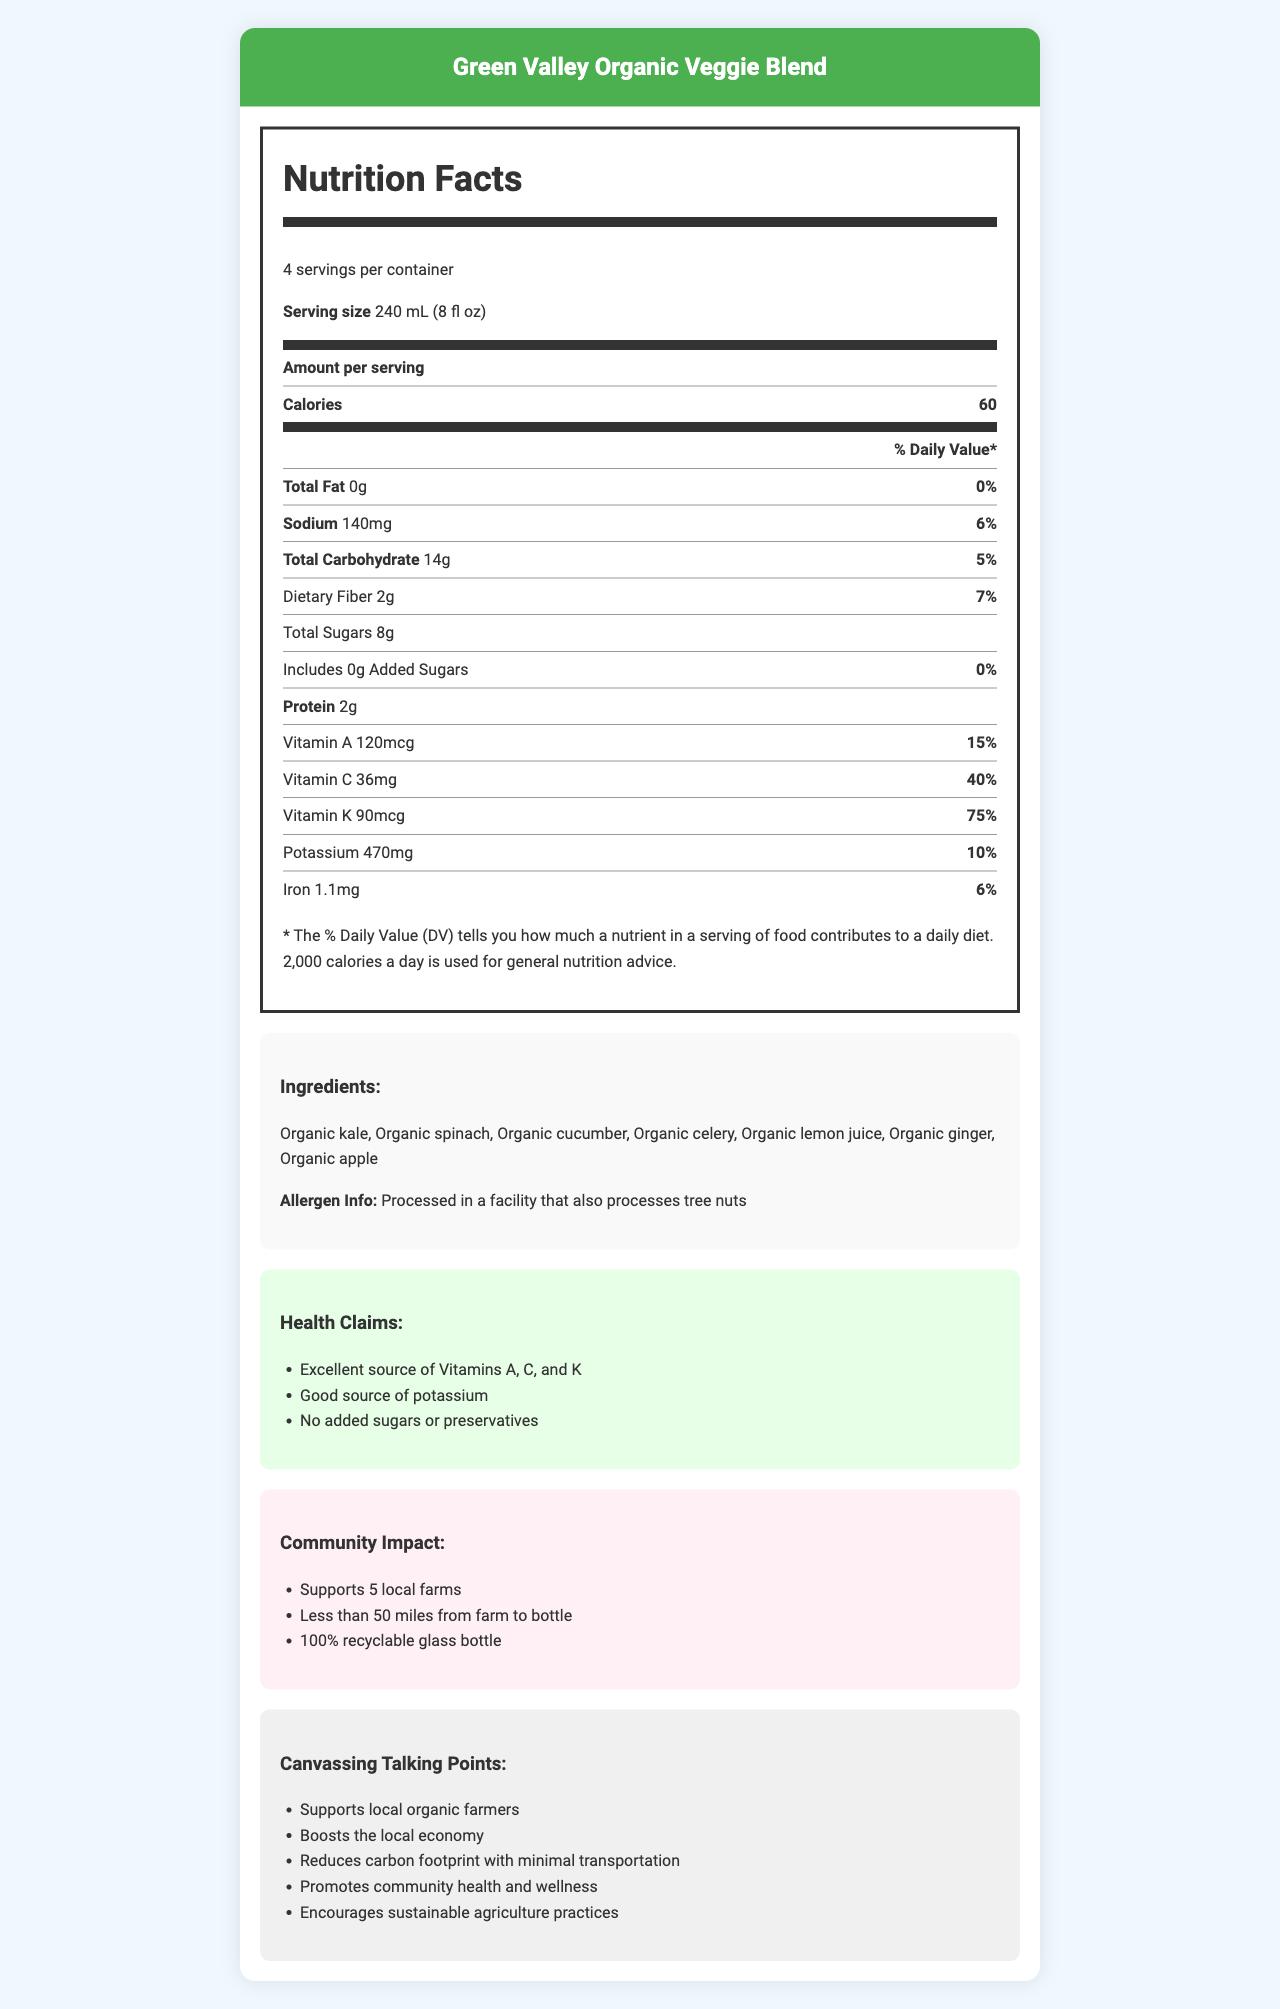what is the product name? The document title and various sections mention the product name as "Green Valley Organic Veggie Blend".
Answer: Green Valley Organic Veggie Blend what is the serving size of the veggie blend? The serving size is listed under the Nutrition Facts section.
Answer: 240 mL (8 fl oz) how many servings are there per container? It says "4 servings per container" under the Nutrition Facts section.
Answer: 4 servings how many calories are in one serving? The number of calories is mentioned in the Amount per serving row under the Nutrition Facts section.
Answer: 60 calories how much total fat is there per serving? Under the Total Fat row in the Nutrition Facts section, it lists 0g.
Answer: 0g what percentage of the daily value of sodium does one serving contain? The Sodium row in Nutrition Facts indicates 140mg or 6% of the daily value.
Answer: 6% what is the daily value percentage of Vitamin K in one serving? A. 15% B. 40% C. 75% D. 10% The Vitamin K row states it contains 75% of the daily value.
Answer: C which vitamin has the highest daily value percentage in the blend? A. Vitamin A B. Vitamin C C. Vitamin K D. Iron Vitamin K has the highest daily value percentage with 75%, compared to Vitamin A's 15%, Vitamin C's 40%, and Iron's 6%.
Answer: C does the veggie blend contain any added sugars? The Total Sugars row indicates 0g of added sugars with a daily value of 0%.
Answer: No is the product processed in a facility that handles allergens? The Ingredients section mentions it is processed in a facility that also processes tree nuts.
Answer: Yes how many local farms does the product support? The Community Impact section mentions support for 5 local farms.
Answer: 5 local farms from the farm to the bottle, how far is the product transported? The Community Impact section states it is transported less than 50 miles.
Answer: Less than 50 miles describe the main idea of the document. The document details nutritional information, ingredient list, allergen info, health claims, community impact, and talking points for canvassing.
Answer: The document provides comprehensive nutritional information about the "Green Valley Organic Veggie Blend", highlighting its health benefits, ingredients, and positive community impact such as supporting local farms and using sustainable packaging. does the blend contain preservatives? Under Health Claims, it states "No added sugars or preservatives".
Answer: No, it does not contain preservatives. what are the listed benefits of the Green Valley Organic Veggie Blend? The Canvassing Talking Points section lists these points as benefits.
Answer: Supports local organic farmers, boosts the local economy, reduces carbon footprint, promotes community health and wellness, encourages sustainable agriculture practices where is the product processed? The document mentions that it is processed in a facility that also processes tree nuts, but does not specify the exact location of the facility.
Answer: Not enough information 